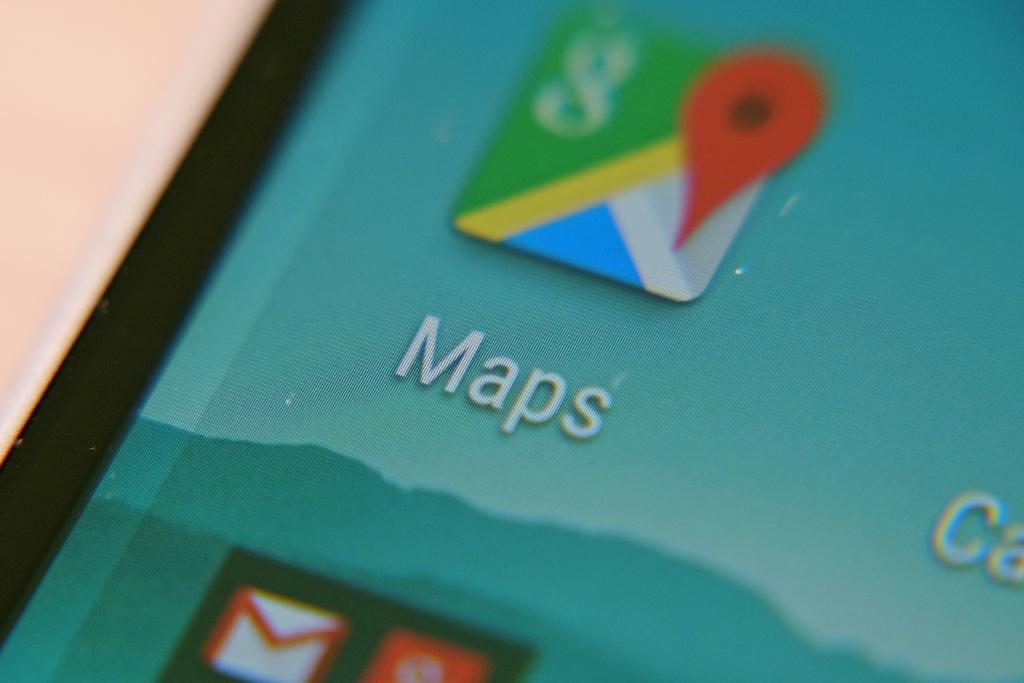<image>
Describe the image concisely. A phone screen shows an app called Maps that has a colorful map icon. 